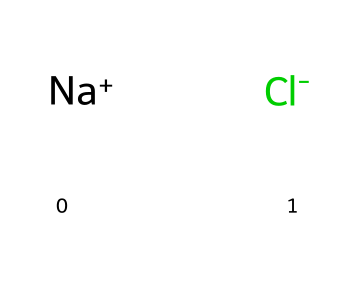What are the two elements in this chemical structure? The SMILES representation shows two separate ions: sodium ion (Na+) and chloride ion (Cl-). Therefore, the elements present are sodium and chlorine.
Answer: sodium and chlorine How many total atoms are represented in the structure? The SMILES representation indicates 1 sodium ion and 1 chloride ion, totaling to 2 atoms in the structure.
Answer: 2 What type of bond exists between sodium and chloride in this chemical? Sodium chloride (NaCl) forms through ionic bonding, where sodium donates an electron to chlorine, creating oppositely charged ions that attract each other.
Answer: ionic bond What is the primary nutritional role of sodium chloride in the body? Sodium chloride is essential for maintaining fluid balance and proper nerve and muscle function in the body.
Answer: fluid balance What does the "+" and "-" denote in the SMILES representation? The "+" sign denotes a positively charged sodium ion (Na+), while the "-" sign indicates a negatively charged chloride ion (Cl-). The charges signify the ionic nature of the compound.
Answer: charges Why is the crystalline structure of sodium chloride important for its properties? The crystalline structure allows for optimal packing of the ions, leading to high stability, distinct melting and boiling points due to the strong ionic interactions between the Na+ and Cl- ions.
Answer: stability 